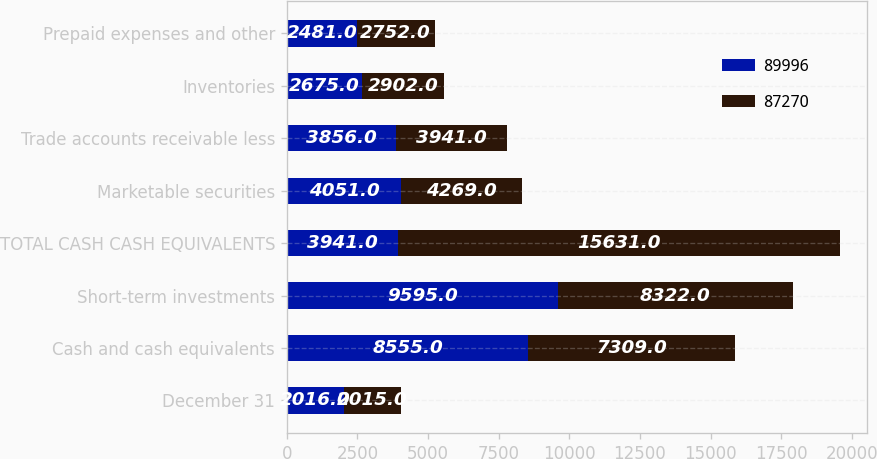<chart> <loc_0><loc_0><loc_500><loc_500><stacked_bar_chart><ecel><fcel>December 31<fcel>Cash and cash equivalents<fcel>Short-term investments<fcel>TOTAL CASH CASH EQUIVALENTS<fcel>Marketable securities<fcel>Trade accounts receivable less<fcel>Inventories<fcel>Prepaid expenses and other<nl><fcel>89996<fcel>2016<fcel>8555<fcel>9595<fcel>3941<fcel>4051<fcel>3856<fcel>2675<fcel>2481<nl><fcel>87270<fcel>2015<fcel>7309<fcel>8322<fcel>15631<fcel>4269<fcel>3941<fcel>2902<fcel>2752<nl></chart> 